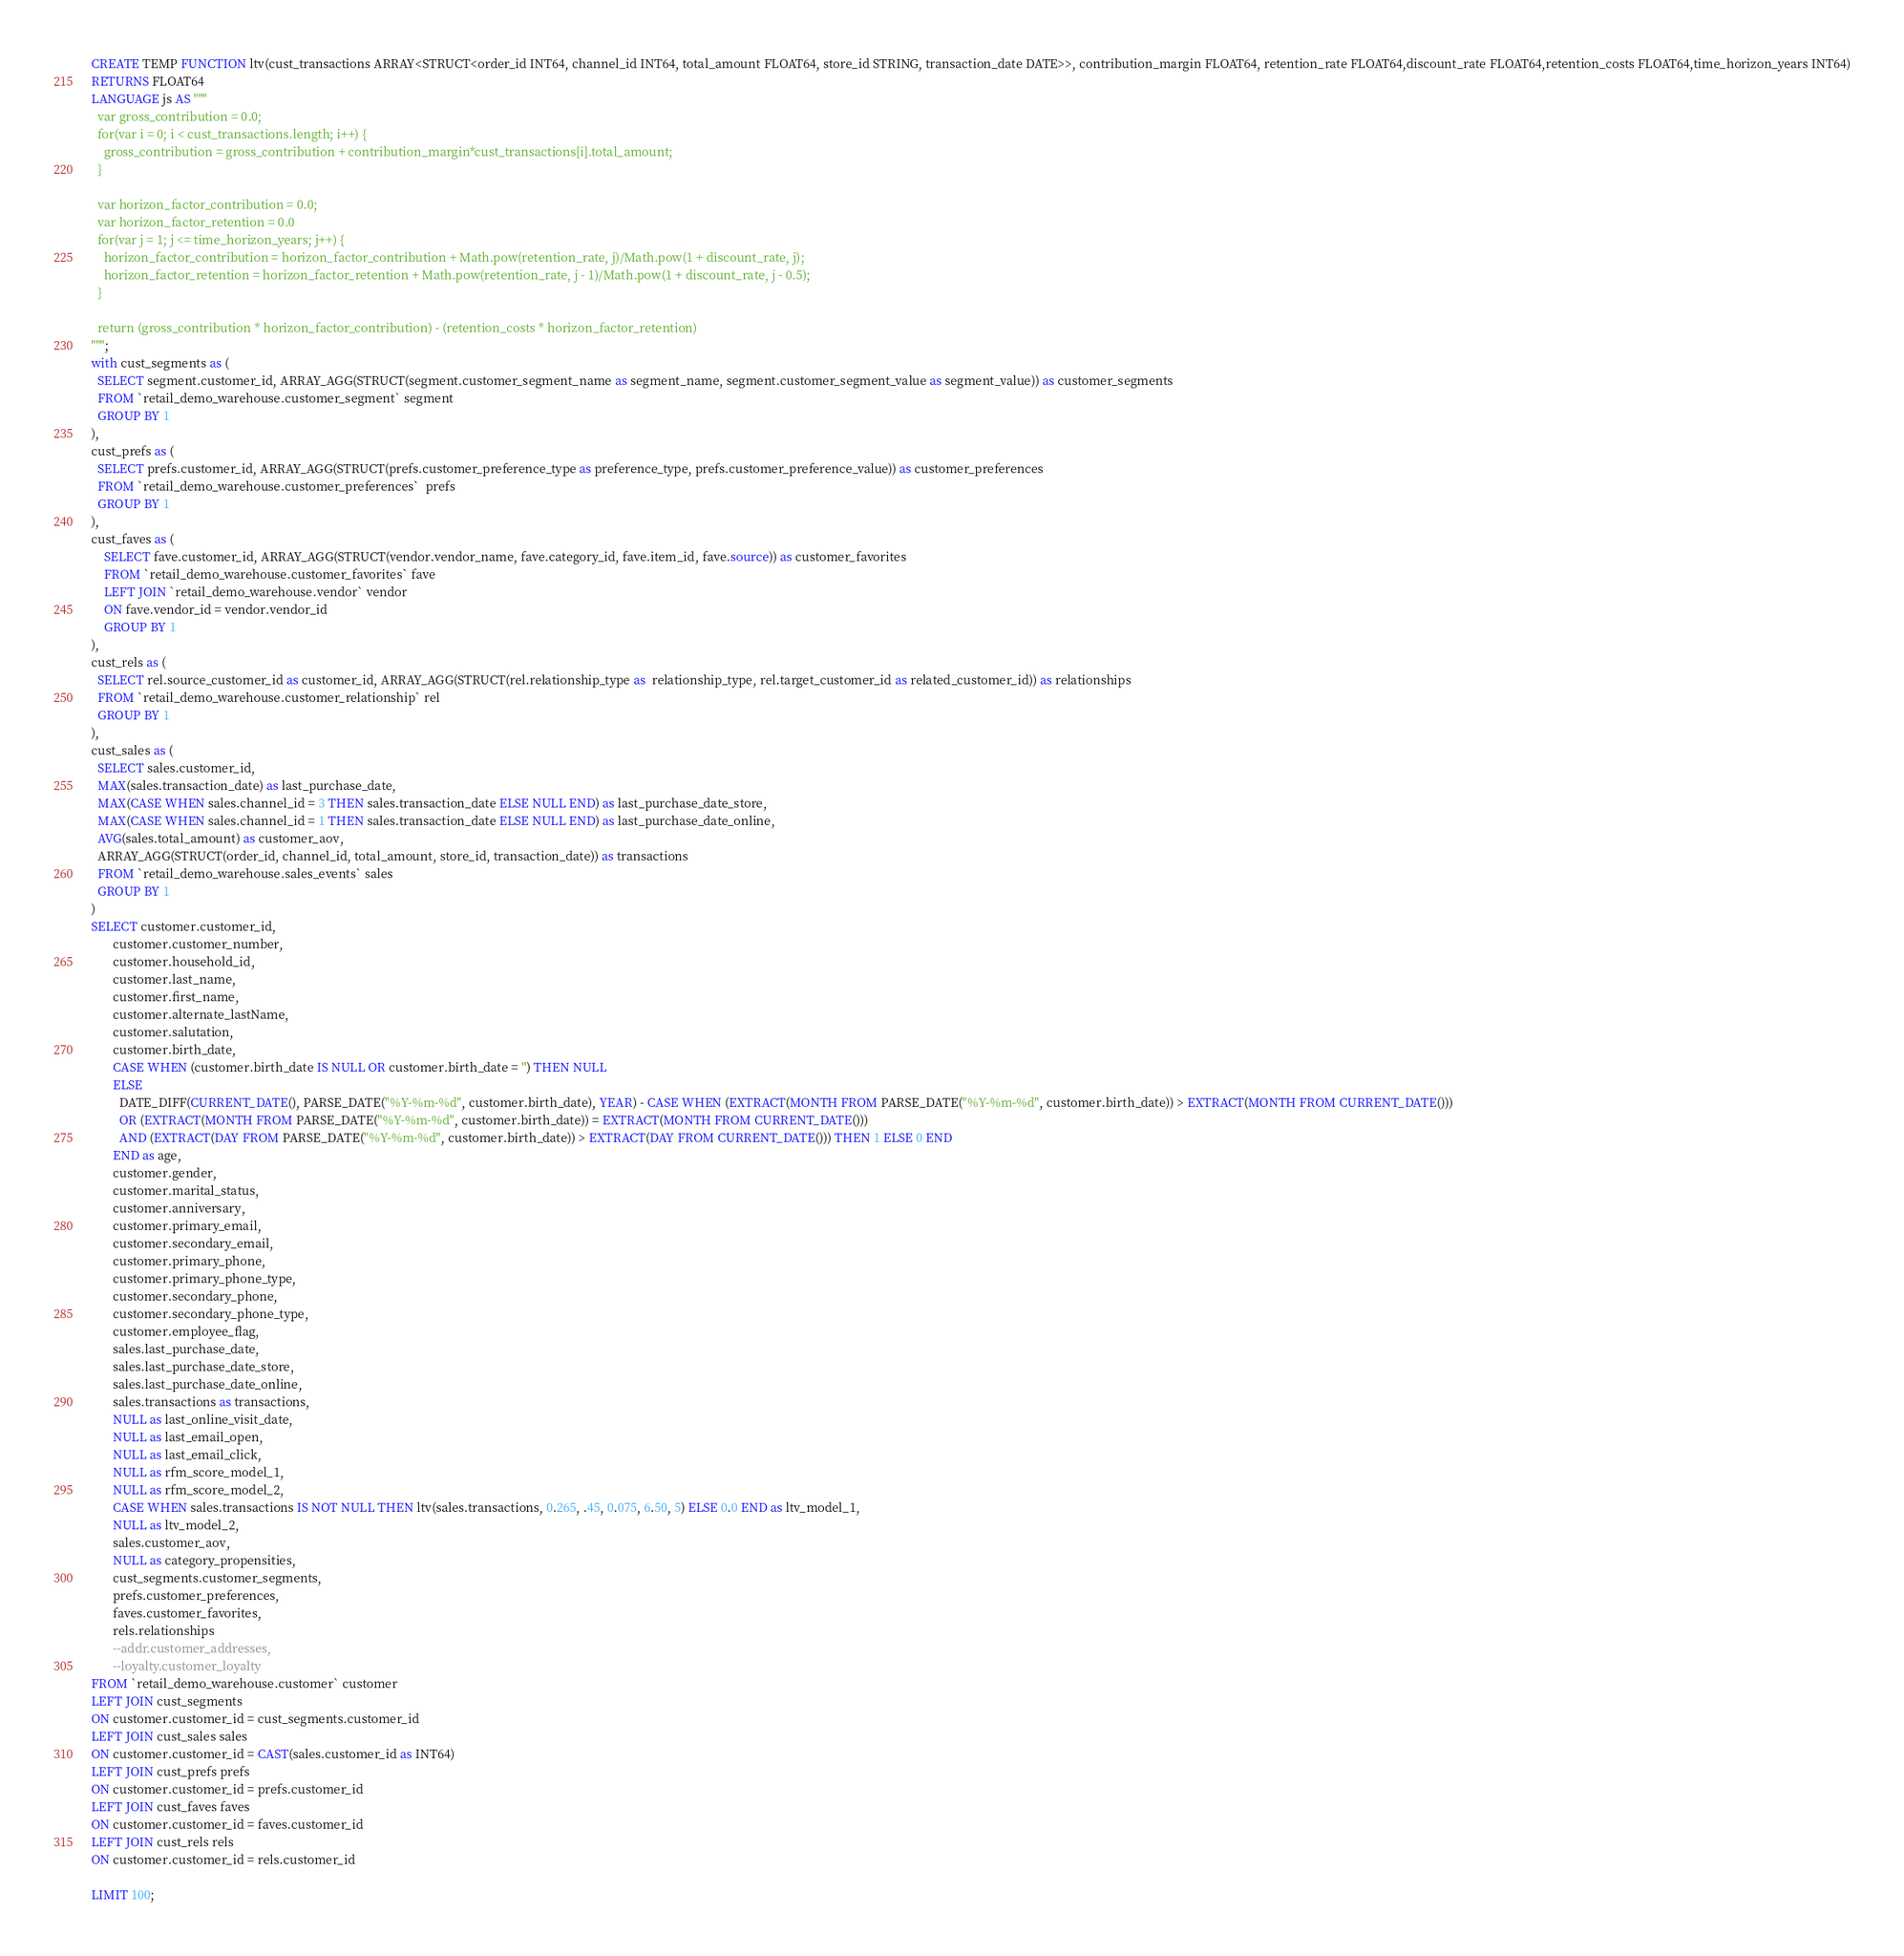<code> <loc_0><loc_0><loc_500><loc_500><_SQL_>CREATE TEMP FUNCTION ltv(cust_transactions ARRAY<STRUCT<order_id INT64, channel_id INT64, total_amount FLOAT64, store_id STRING, transaction_date DATE>>, contribution_margin FLOAT64, retention_rate FLOAT64,discount_rate FLOAT64,retention_costs FLOAT64,time_horizon_years INT64)
RETURNS FLOAT64
LANGUAGE js AS """
  var gross_contribution = 0.0;
  for(var i = 0; i < cust_transactions.length; i++) {
    gross_contribution = gross_contribution + contribution_margin*cust_transactions[i].total_amount;
  }

  var horizon_factor_contribution = 0.0;
  var horizon_factor_retention = 0.0
  for(var j = 1; j <= time_horizon_years; j++) {
    horizon_factor_contribution = horizon_factor_contribution + Math.pow(retention_rate, j)/Math.pow(1 + discount_rate, j);
    horizon_factor_retention = horizon_factor_retention + Math.pow(retention_rate, j - 1)/Math.pow(1 + discount_rate, j - 0.5);
  }

  return (gross_contribution * horizon_factor_contribution) - (retention_costs * horizon_factor_retention)
""";
with cust_segments as (
  SELECT segment.customer_id, ARRAY_AGG(STRUCT(segment.customer_segment_name as segment_name, segment.customer_segment_value as segment_value)) as customer_segments
  FROM `retail_demo_warehouse.customer_segment` segment
  GROUP BY 1
),
cust_prefs as (
  SELECT prefs.customer_id, ARRAY_AGG(STRUCT(prefs.customer_preference_type as preference_type, prefs.customer_preference_value)) as customer_preferences
  FROM `retail_demo_warehouse.customer_preferences`  prefs
  GROUP BY 1
),
cust_faves as (
    SELECT fave.customer_id, ARRAY_AGG(STRUCT(vendor.vendor_name, fave.category_id, fave.item_id, fave.source)) as customer_favorites
    FROM `retail_demo_warehouse.customer_favorites` fave
    LEFT JOIN `retail_demo_warehouse.vendor` vendor
    ON fave.vendor_id = vendor.vendor_id
    GROUP BY 1
),
cust_rels as (
  SELECT rel.source_customer_id as customer_id, ARRAY_AGG(STRUCT(rel.relationship_type as  relationship_type, rel.target_customer_id as related_customer_id)) as relationships
  FROM `retail_demo_warehouse.customer_relationship` rel
  GROUP BY 1
),
cust_sales as (
  SELECT sales.customer_id,
  MAX(sales.transaction_date) as last_purchase_date,
  MAX(CASE WHEN sales.channel_id = 3 THEN sales.transaction_date ELSE NULL END) as last_purchase_date_store,
  MAX(CASE WHEN sales.channel_id = 1 THEN sales.transaction_date ELSE NULL END) as last_purchase_date_online,
  AVG(sales.total_amount) as customer_aov,
  ARRAY_AGG(STRUCT(order_id, channel_id, total_amount, store_id, transaction_date)) as transactions
  FROM `retail_demo_warehouse.sales_events` sales
  GROUP BY 1
)
SELECT customer.customer_id,
       customer.customer_number,
       customer.household_id,
       customer.last_name,
       customer.first_name,
       customer.alternate_lastName,
       customer.salutation,
       customer.birth_date,
       CASE WHEN (customer.birth_date IS NULL OR customer.birth_date = '') THEN NULL
       ELSE
         DATE_DIFF(CURRENT_DATE(), PARSE_DATE("%Y-%m-%d", customer.birth_date), YEAR) - CASE WHEN (EXTRACT(MONTH FROM PARSE_DATE("%Y-%m-%d", customer.birth_date)) > EXTRACT(MONTH FROM CURRENT_DATE()))
         OR (EXTRACT(MONTH FROM PARSE_DATE("%Y-%m-%d", customer.birth_date)) = EXTRACT(MONTH FROM CURRENT_DATE()))
         AND (EXTRACT(DAY FROM PARSE_DATE("%Y-%m-%d", customer.birth_date)) > EXTRACT(DAY FROM CURRENT_DATE())) THEN 1 ELSE 0 END
       END as age,
       customer.gender,
       customer.marital_status,
       customer.anniversary,
       customer.primary_email,
       customer.secondary_email,
       customer.primary_phone,
       customer.primary_phone_type,
       customer.secondary_phone,
       customer.secondary_phone_type,
       customer.employee_flag,
       sales.last_purchase_date,
       sales.last_purchase_date_store,
       sales.last_purchase_date_online,
       sales.transactions as transactions,
       NULL as last_online_visit_date,
       NULL as last_email_open,
       NULL as last_email_click,
       NULL as rfm_score_model_1,
       NULL as rfm_score_model_2,
       CASE WHEN sales.transactions IS NOT NULL THEN ltv(sales.transactions, 0.265, .45, 0.075, 6.50, 5) ELSE 0.0 END as ltv_model_1,
       NULL as ltv_model_2,
       sales.customer_aov,
       NULL as category_propensities,
       cust_segments.customer_segments,
       prefs.customer_preferences,
       faves.customer_favorites,
       rels.relationships
       --addr.customer_addresses,
       --loyalty.customer_loyalty
FROM `retail_demo_warehouse.customer` customer
LEFT JOIN cust_segments
ON customer.customer_id = cust_segments.customer_id
LEFT JOIN cust_sales sales
ON customer.customer_id = CAST(sales.customer_id as INT64)
LEFT JOIN cust_prefs prefs
ON customer.customer_id = prefs.customer_id
LEFT JOIN cust_faves faves
ON customer.customer_id = faves.customer_id
LEFT JOIN cust_rels rels
ON customer.customer_id = rels.customer_id

LIMIT 100;
</code> 